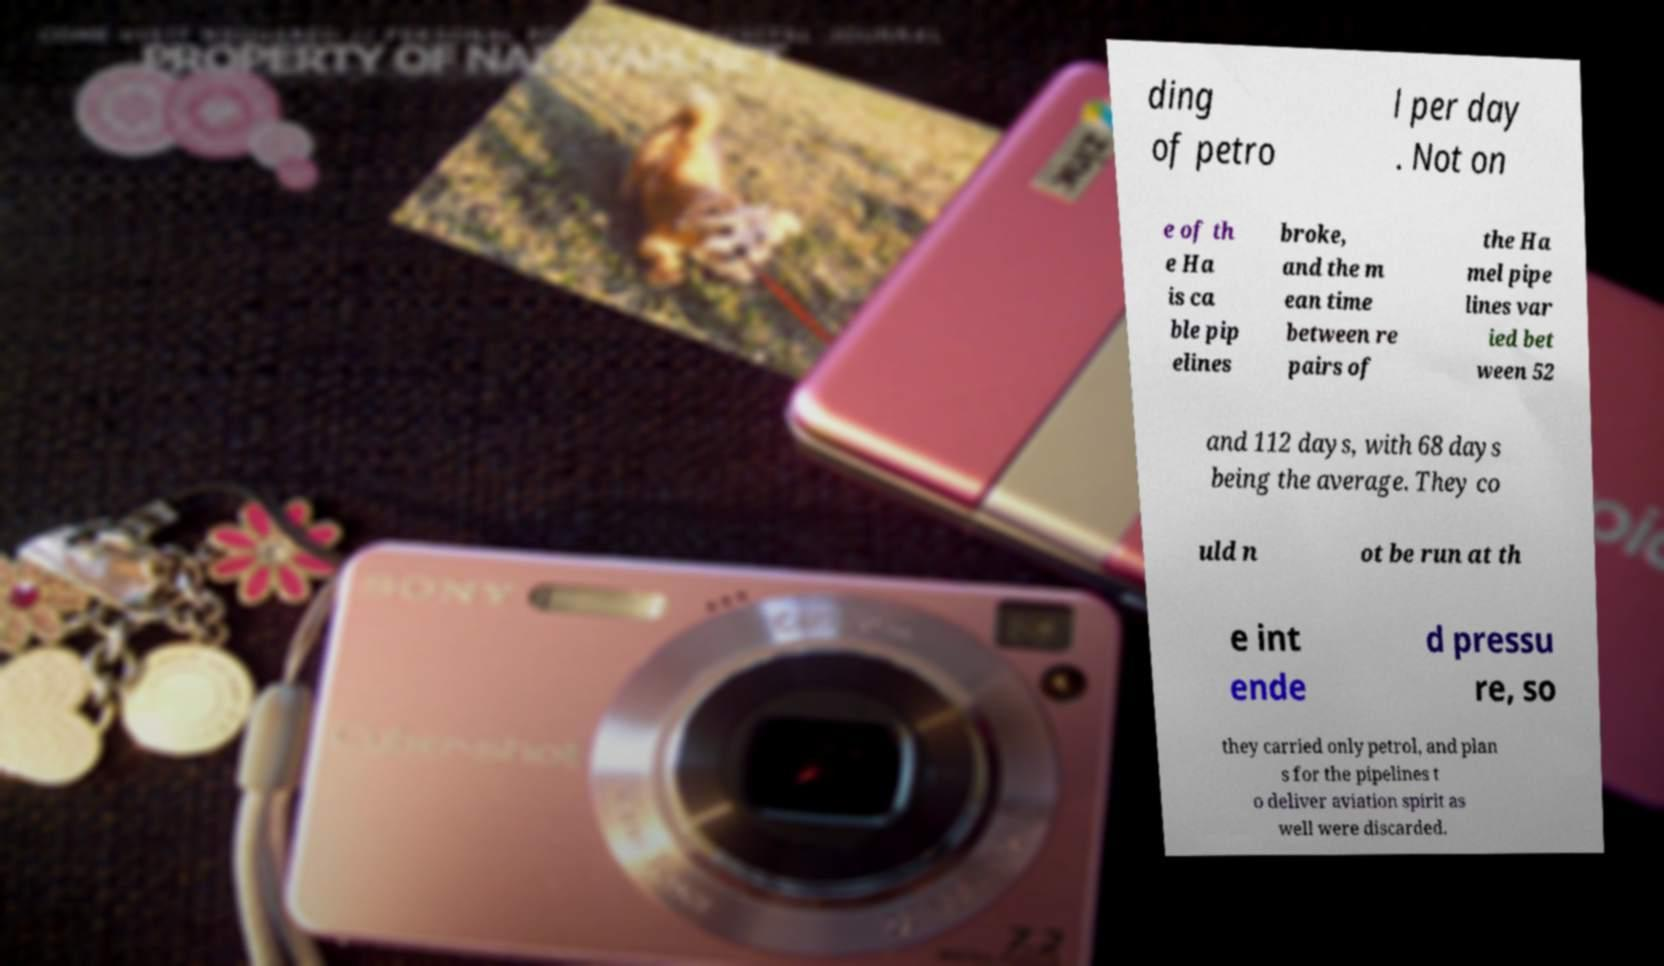I need the written content from this picture converted into text. Can you do that? ding of petro l per day . Not on e of th e Ha is ca ble pip elines broke, and the m ean time between re pairs of the Ha mel pipe lines var ied bet ween 52 and 112 days, with 68 days being the average. They co uld n ot be run at th e int ende d pressu re, so they carried only petrol, and plan s for the pipelines t o deliver aviation spirit as well were discarded. 